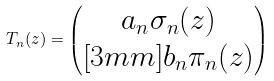<formula> <loc_0><loc_0><loc_500><loc_500>T _ { n } ( z ) = \begin{pmatrix} a _ { n } \sigma _ { n } ( z ) \\ [ 3 m m ] b _ { n } \pi _ { n } ( z ) \\ \end{pmatrix}</formula> 